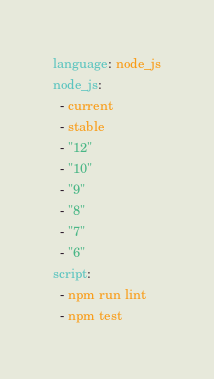Convert code to text. <code><loc_0><loc_0><loc_500><loc_500><_YAML_>language: node_js
node_js:
  - current
  - stable
  - "12"
  - "10"
  - "9"
  - "8"
  - "7"
  - "6"
script:
  - npm run lint
  - npm test
</code> 